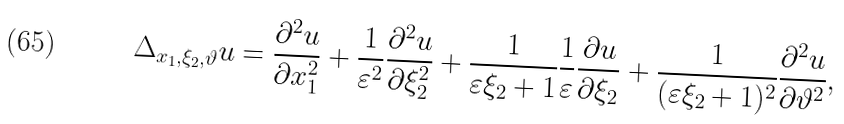<formula> <loc_0><loc_0><loc_500><loc_500>\Delta _ { x _ { 1 } , \xi _ { 2 } , \vartheta } u = \frac { \partial ^ { 2 } u } { \partial x _ { 1 } ^ { 2 } } + \frac { 1 } { \varepsilon ^ { 2 } } \frac { \partial ^ { 2 } u } { \partial \xi _ { 2 } ^ { 2 } } + \frac { 1 } { \varepsilon \xi _ { 2 } + 1 } \frac { 1 } { \varepsilon } \frac { \partial u } { \partial \xi _ { 2 } } + \frac { 1 } { ( \varepsilon \xi _ { 2 } + 1 ) ^ { 2 } } \frac { \partial ^ { 2 } u } { \partial \vartheta ^ { 2 } } ,</formula> 